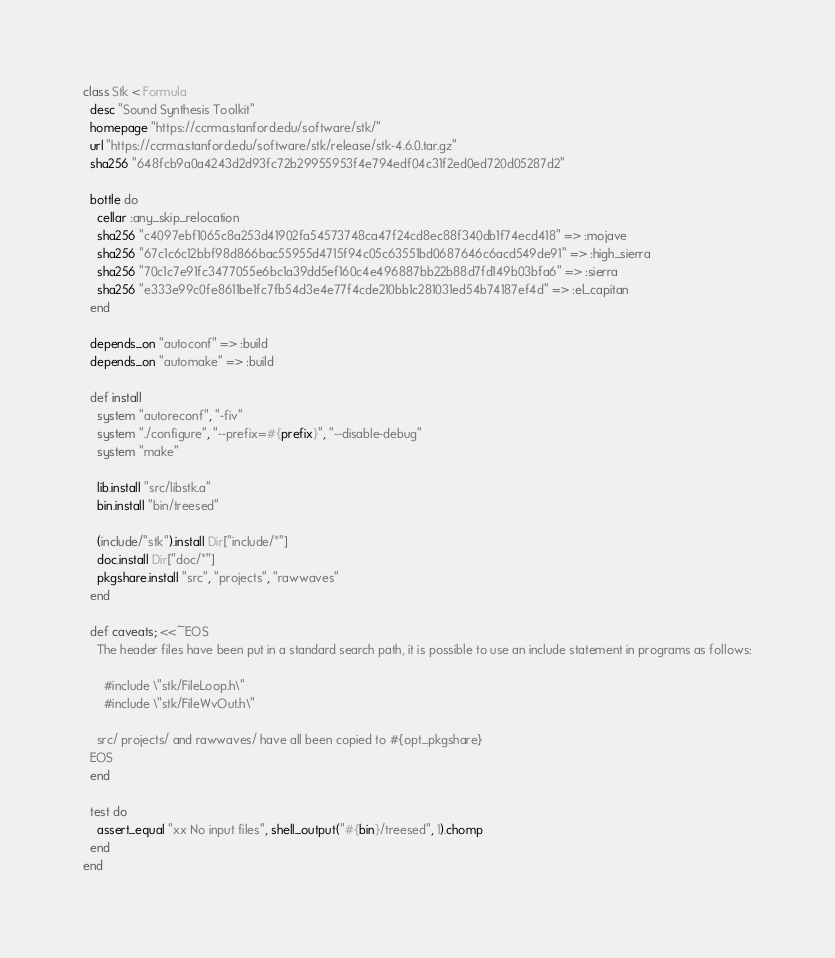Convert code to text. <code><loc_0><loc_0><loc_500><loc_500><_Ruby_>class Stk < Formula
  desc "Sound Synthesis Toolkit"
  homepage "https://ccrma.stanford.edu/software/stk/"
  url "https://ccrma.stanford.edu/software/stk/release/stk-4.6.0.tar.gz"
  sha256 "648fcb9a0a4243d2d93fc72b29955953f4e794edf04c31f2ed0ed720d05287d2"

  bottle do
    cellar :any_skip_relocation
    sha256 "c4097ebf1065c8a253d41902fa54573748ca47f24cd8ec88f340db1f74ecd418" => :mojave
    sha256 "67c1c6c12bbf98d866bac55955d4715f94c05c63551bd0687646c6acd549de91" => :high_sierra
    sha256 "70c1c7e91fc3477055e6bc1a39dd5ef160c4e496887bb22b88d7fd149b03bfa6" => :sierra
    sha256 "e333e99c0fe8611be1fc7fb54d3e4e77f4cde210bb1c281031ed54b74187ef4d" => :el_capitan
  end

  depends_on "autoconf" => :build
  depends_on "automake" => :build

  def install
    system "autoreconf", "-fiv"
    system "./configure", "--prefix=#{prefix}", "--disable-debug"
    system "make"

    lib.install "src/libstk.a"
    bin.install "bin/treesed"

    (include/"stk").install Dir["include/*"]
    doc.install Dir["doc/*"]
    pkgshare.install "src", "projects", "rawwaves"
  end

  def caveats; <<~EOS
    The header files have been put in a standard search path, it is possible to use an include statement in programs as follows:

      #include \"stk/FileLoop.h\"
      #include \"stk/FileWvOut.h\"

    src/ projects/ and rawwaves/ have all been copied to #{opt_pkgshare}
  EOS
  end

  test do
    assert_equal "xx No input files", shell_output("#{bin}/treesed", 1).chomp
  end
end
</code> 